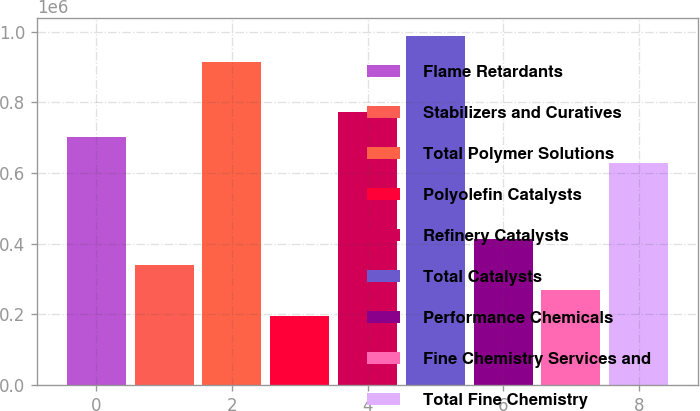<chart> <loc_0><loc_0><loc_500><loc_500><bar_chart><fcel>Flame Retardants<fcel>Stabilizers and Curatives<fcel>Total Polymer Solutions<fcel>Polyolefin Catalysts<fcel>Refinery Catalysts<fcel>Total Catalysts<fcel>Performance Chemicals<fcel>Fine Chemistry Services and<fcel>Total Fine Chemistry<nl><fcel>700749<fcel>340469<fcel>915515<fcel>194645<fcel>773661<fcel>988427<fcel>413380<fcel>267557<fcel>627837<nl></chart> 